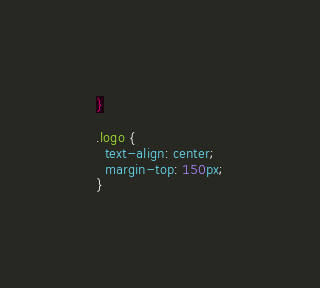<code> <loc_0><loc_0><loc_500><loc_500><_CSS_>}

.logo {
  text-align: center;
  margin-top: 150px;
}
</code> 